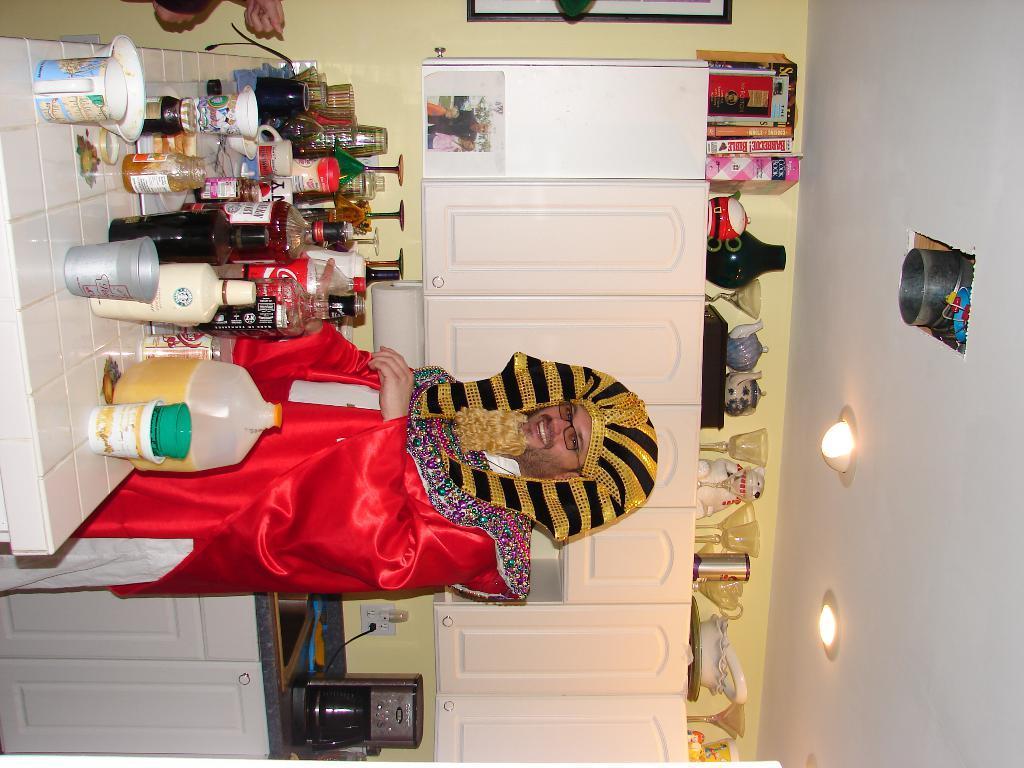Can you describe this image briefly? In this picture we can see a person, he is smiling, here we can see a kitchen platform, sink, bottles, cups, cupboards, boxes, jars and some objects. In the background we can see a wall, roof, lights. 